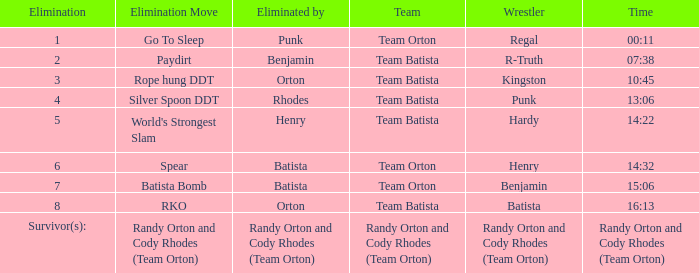Which Wrestler plays for Team Batista which was Elimated by Orton on Elimination 8? Batista. 